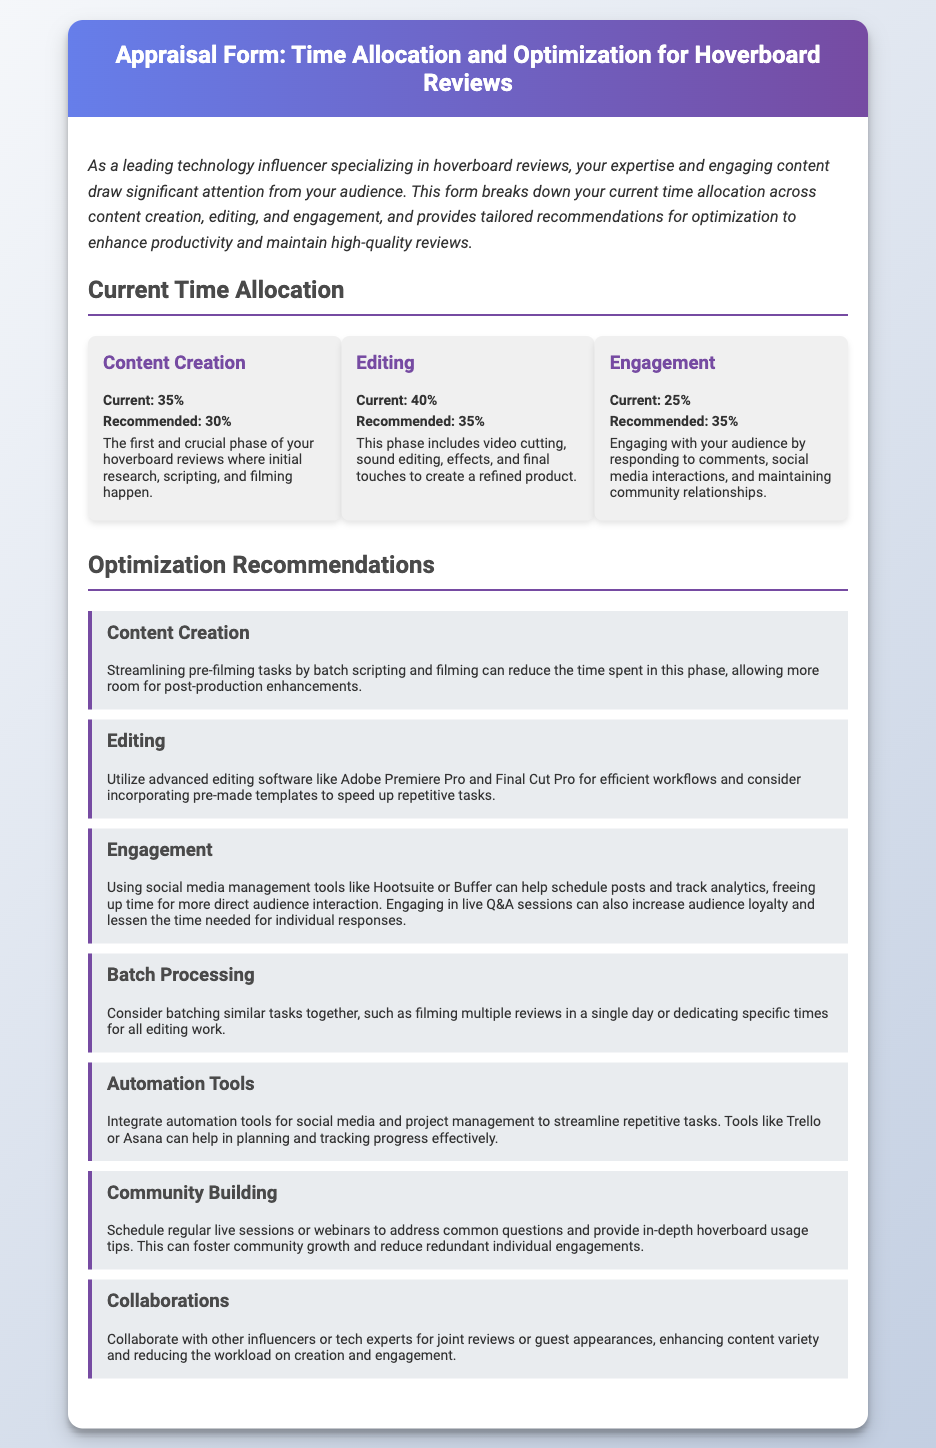What is the current percentage allocation for Content Creation? The current percentage allocation for Content Creation is mentioned in the document under Current Time Allocation.
Answer: 35% What phase includes video cutting and sound editing? This phase is detailed in the section on Current Time Allocation, specifically under Editing.
Answer: Editing What is the recommended percentage for Engagement? The recommended percentage for Engagement is listed in the document under Recommendations.
Answer: 35% Which software is suggested for improving editing efficiency? The document mentions specific software tools in the Optimization Recommendations under Editing.
Answer: Adobe Premiere Pro What is the first phase of hoverboard reviews according to the document? This is described in the Current Time Allocation section regarding the content creation process.
Answer: Content Creation How much of the total time is currently allocated to Editing? This percentage is stated clearly under Current Time Allocation.
Answer: 40% What kind of sessions can foster community growth? This is mentioned in the section regarding Engagement recommendations.
Answer: Live sessions What is a recommendation for collaboration in content creation? The document suggests actions in the Optimization Recommendations for improving content variety.
Answer: Collaborate with other influencers 